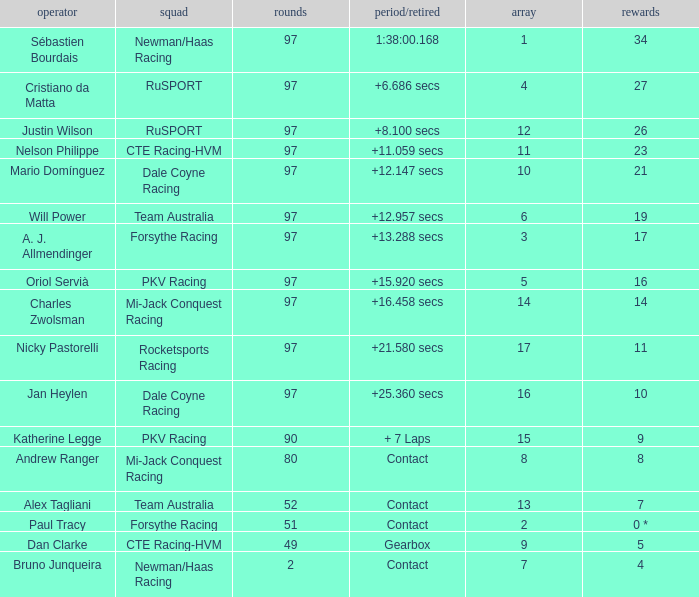What is the highest number of laps for the driver with 5 points? 49.0. Give me the full table as a dictionary. {'header': ['operator', 'squad', 'rounds', 'period/retired', 'array', 'rewards'], 'rows': [['Sébastien Bourdais', 'Newman/Haas Racing', '97', '1:38:00.168', '1', '34'], ['Cristiano da Matta', 'RuSPORT', '97', '+6.686 secs', '4', '27'], ['Justin Wilson', 'RuSPORT', '97', '+8.100 secs', '12', '26'], ['Nelson Philippe', 'CTE Racing-HVM', '97', '+11.059 secs', '11', '23'], ['Mario Domínguez', 'Dale Coyne Racing', '97', '+12.147 secs', '10', '21'], ['Will Power', 'Team Australia', '97', '+12.957 secs', '6', '19'], ['A. J. Allmendinger', 'Forsythe Racing', '97', '+13.288 secs', '3', '17'], ['Oriol Servià', 'PKV Racing', '97', '+15.920 secs', '5', '16'], ['Charles Zwolsman', 'Mi-Jack Conquest Racing', '97', '+16.458 secs', '14', '14'], ['Nicky Pastorelli', 'Rocketsports Racing', '97', '+21.580 secs', '17', '11'], ['Jan Heylen', 'Dale Coyne Racing', '97', '+25.360 secs', '16', '10'], ['Katherine Legge', 'PKV Racing', '90', '+ 7 Laps', '15', '9'], ['Andrew Ranger', 'Mi-Jack Conquest Racing', '80', 'Contact', '8', '8'], ['Alex Tagliani', 'Team Australia', '52', 'Contact', '13', '7'], ['Paul Tracy', 'Forsythe Racing', '51', 'Contact', '2', '0 *'], ['Dan Clarke', 'CTE Racing-HVM', '49', 'Gearbox', '9', '5'], ['Bruno Junqueira', 'Newman/Haas Racing', '2', 'Contact', '7', '4']]} 